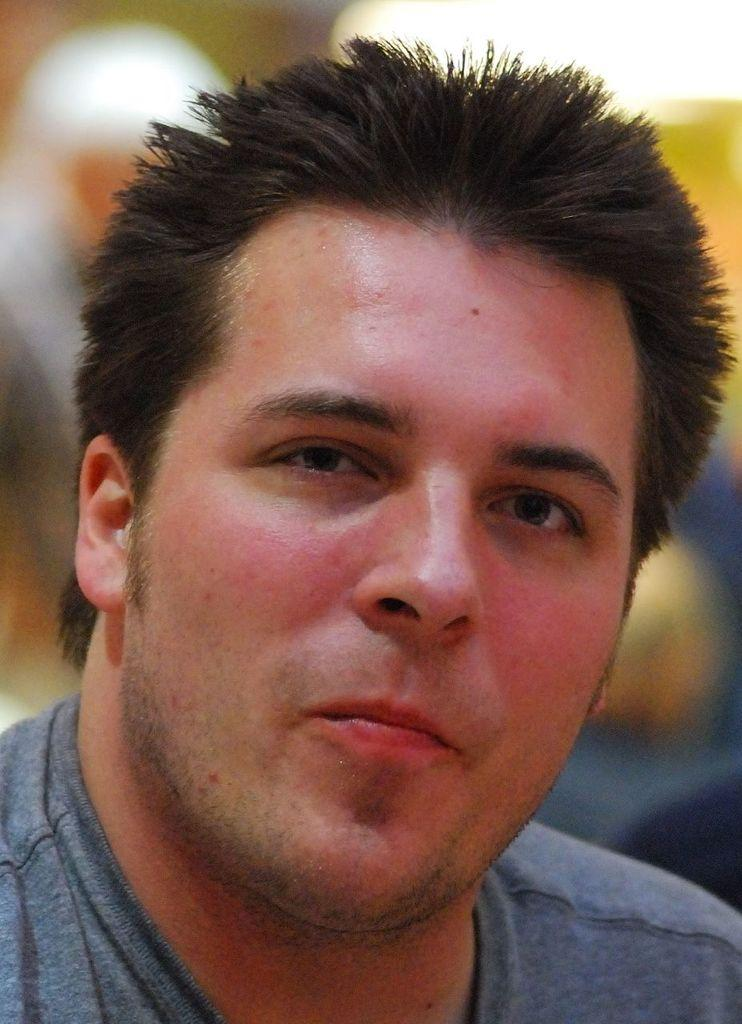What is present in the image? There is a person in the image. Can you describe the person's clothing? The person is wearing a t-shirt. What type of hose is being used by the person in the image? There is no hose present in the image. Where can the person be seen shopping in the image? There is no shop or shopping activity depicted in the image. 